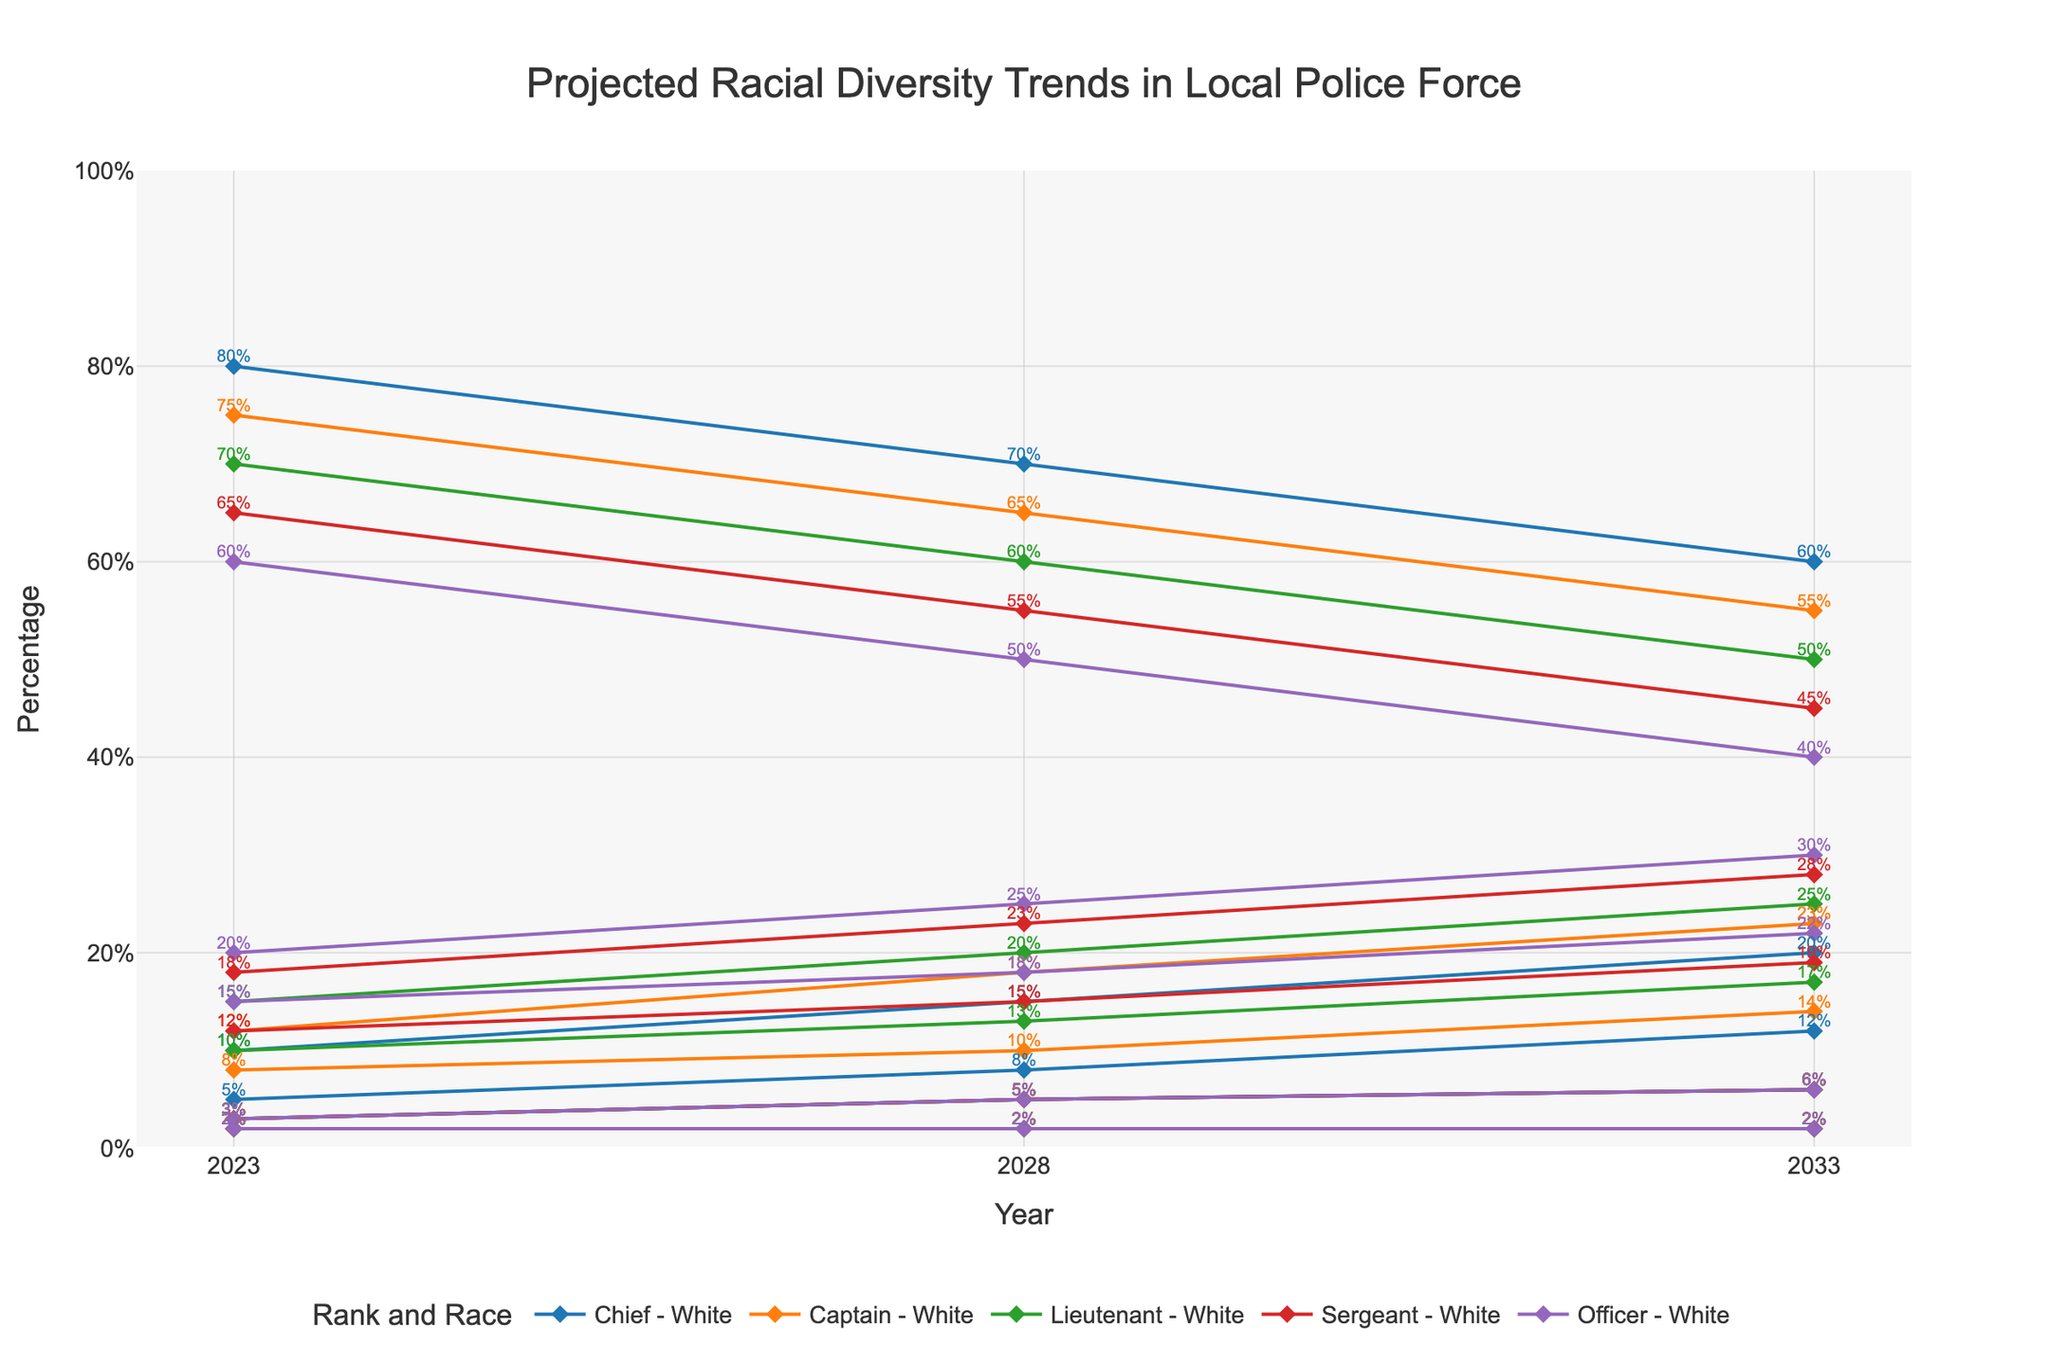what is the title of the figure? The title is prominently placed at the top of the figure, usually in a larger font, and it summarizes what the plot is about. Here, it reads "Projected Racial Diversity Trends in Local Police Force".
Answer: Projected Racial Diversity Trends in Local Police Force Which rank is projected to have the highest percentage of Black officers in 2033? To answer this, you need to look at the lines representing each rank for Black officers in 2033 and identify the highest percentage. For 2033, the ranks have the following percentages for Black officers: Chief (20%), Captain (23%), Lieutenant (25%), Sergeant (28%), and Officer (30%). The highest percentage is observed for the Officer rank.
Answer: Officer By what percentage is the representation of White officers expected to decrease for the Chief rank from 2023 to 2033? Calculate the difference by subtracting the percentage of White Chief officers in 2033 from 2023. In 2023, the percentage is 80%, and in 2033 it is 60%. The decrease is 80% - 60% = 20%.
Answer: 20% What is the trend for Hispanic officers at the Lieutenant rank over the next 10 years? Observe the line for Hispanic officers at the Lieutenant rank across the years 2023 to 2033. The line shows percentages increasing from 2023 (10%) to 2028 (13%) to 2033 (17%), indicating an increasing trend.
Answer: Increasing Which racial group at the Sergeant rank shows the smallest projected change in percentage from 2023 to 2033? Compare the percentage changes for each racial group at the Sergeant rank across the years. The smallest change occurs for the 'Other' category which remains constant at 2% from 2023 to 2033.
Answer: Other Are the percentages of Asian officers projected to remain the same for any rank from 2023 to 2033? Look at the projection for Asian officers for each rank over the years. The line for Asian officers remains at 3% in 2023, 2028, and 2033 across all ranks, indicating no change.
Answer: Yes How does the percentage of Hispanic officers in the Captain rank compare in 2028 and 2033? To find this out, note the percentages of Hispanic officers in the Captain rank for the years 2028 and 2033. In 2028 it's 10%, and in 2033 it's 14%. Comparing these, 2033 shows a 4% increase from 2028.
Answer: 4% increase What is the projected percentage of Black officers for the entire police force in 2028 if the percentages remain constant across ranks? (assume equal distributions across ranks) First, find the percentage of Black officers in each rank in 2028, then calculate the average: [(15+18+20+23+25)/5] = 20.2%
Answer: 20.2% By how much is the representation of Black officers expected to increase for each rank (Chief, Captain, Lieutenant, Sergeant, Officer) from 2023 to 2033? Calculate the increase for each rank: Chief (20%-10%=10%), Captain (23%-12%=11%), Lieutenant (25%-15%=10%), Sergeant (28%-18%=10%), Officer (30%-20%=10%). The representation increases by 10%-11% for each rank.
Answer: 10% - 11% 